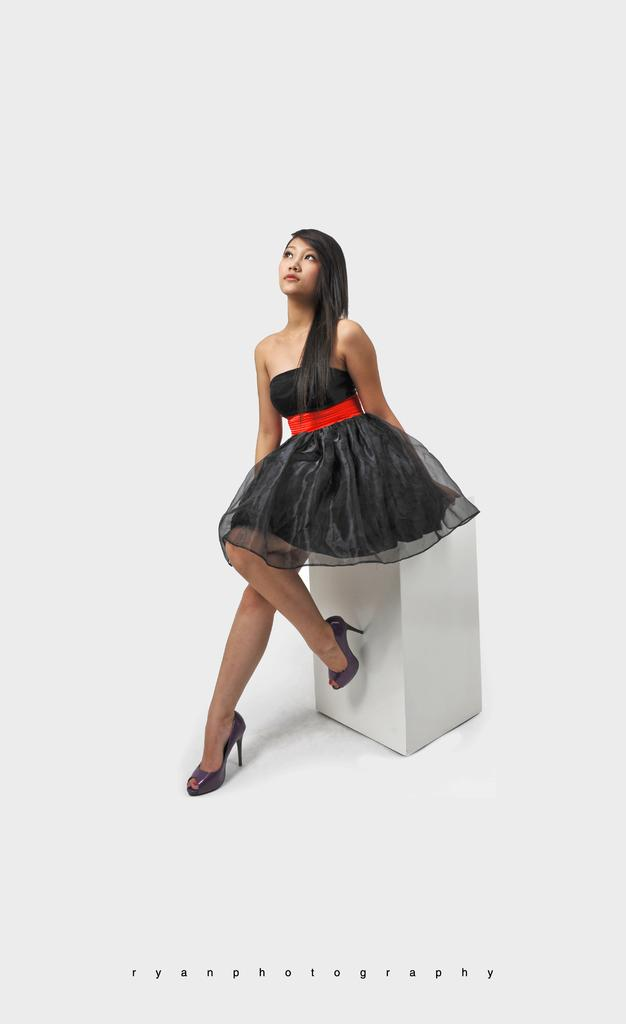Who is the main subject in the image? There is a lady in the image. What is the lady sitting on in the image? The lady is sitting on a cube stool. What is the color of the cube stool? The cube stool is in white color. Is the lady in the image involved in a fight with a ghost? There is no indication of a fight or a ghost in the image; it only shows a lady sitting on a white cube stool. 